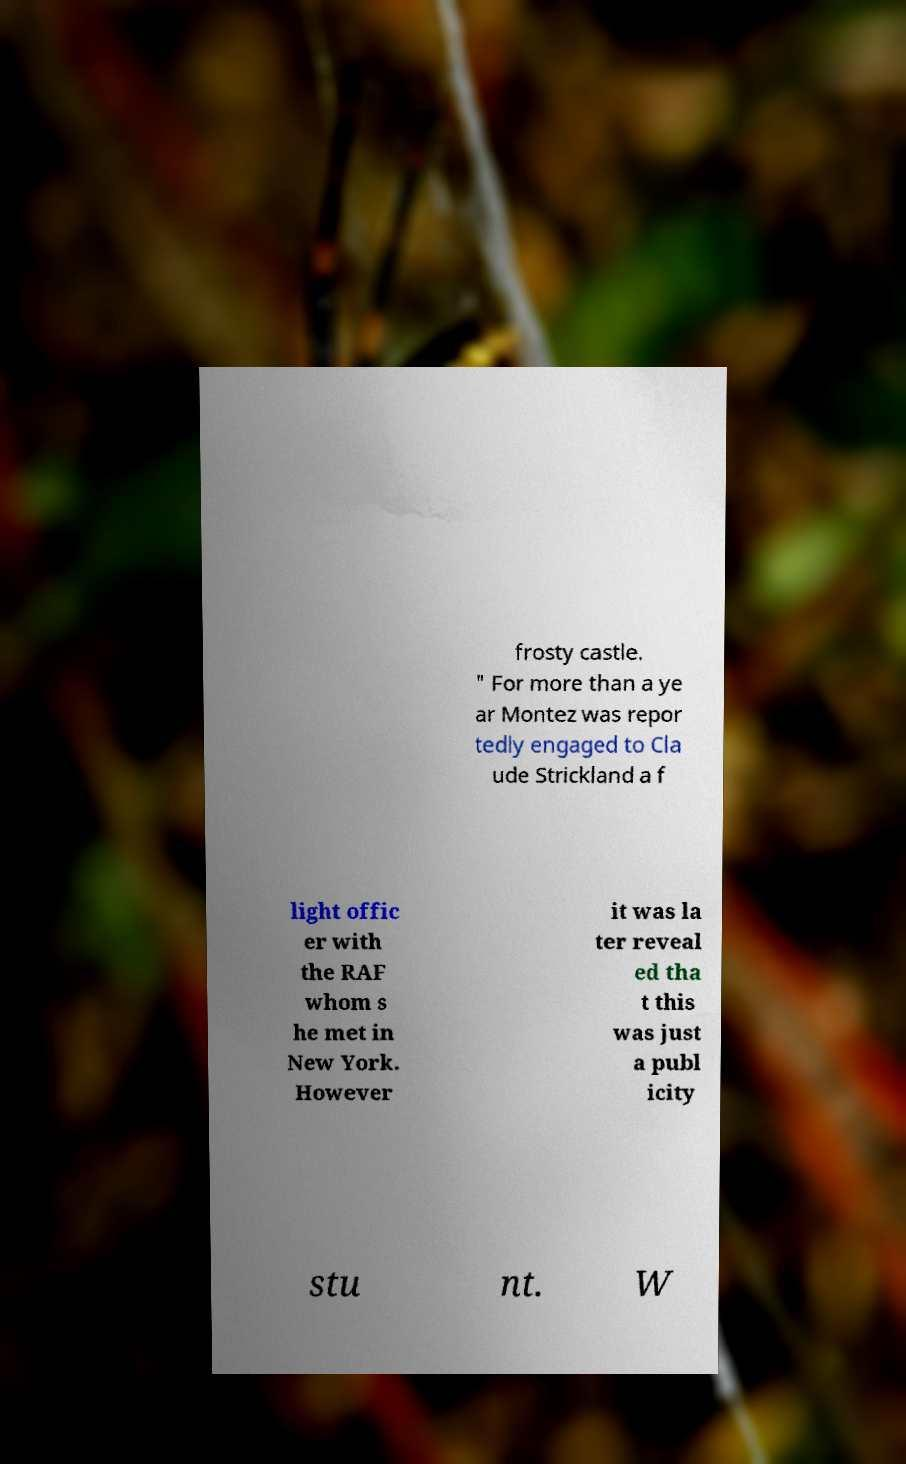Can you accurately transcribe the text from the provided image for me? frosty castle. " For more than a ye ar Montez was repor tedly engaged to Cla ude Strickland a f light offic er with the RAF whom s he met in New York. However it was la ter reveal ed tha t this was just a publ icity stu nt. W 